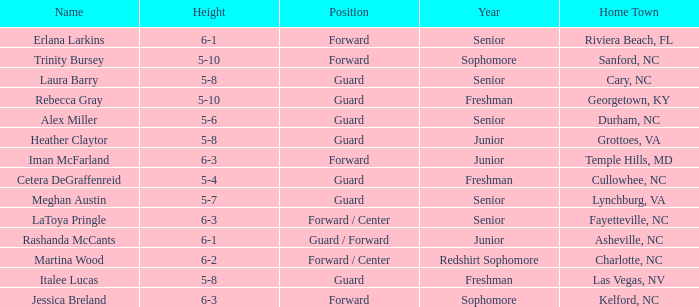What position does the 5-8 player from Grottoes, VA play? Guard. 